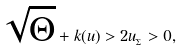Convert formula to latex. <formula><loc_0><loc_0><loc_500><loc_500>\sqrt { \Theta } + k ( u ) > 2 u _ { _ { \Sigma } } > 0 ,</formula> 